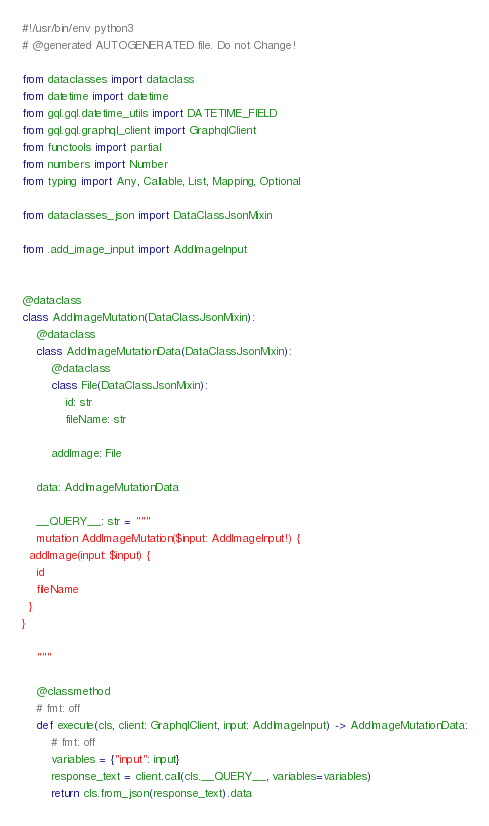<code> <loc_0><loc_0><loc_500><loc_500><_Python_>#!/usr/bin/env python3
# @generated AUTOGENERATED file. Do not Change!

from dataclasses import dataclass
from datetime import datetime
from gql.gql.datetime_utils import DATETIME_FIELD
from gql.gql.graphql_client import GraphqlClient
from functools import partial
from numbers import Number
from typing import Any, Callable, List, Mapping, Optional

from dataclasses_json import DataClassJsonMixin

from .add_image_input import AddImageInput


@dataclass
class AddImageMutation(DataClassJsonMixin):
    @dataclass
    class AddImageMutationData(DataClassJsonMixin):
        @dataclass
        class File(DataClassJsonMixin):
            id: str
            fileName: str

        addImage: File

    data: AddImageMutationData

    __QUERY__: str = """
    mutation AddImageMutation($input: AddImageInput!) {
  addImage(input: $input) {
    id
    fileName
  }
}

    """

    @classmethod
    # fmt: off
    def execute(cls, client: GraphqlClient, input: AddImageInput) -> AddImageMutationData:
        # fmt: off
        variables = {"input": input}
        response_text = client.call(cls.__QUERY__, variables=variables)
        return cls.from_json(response_text).data
</code> 